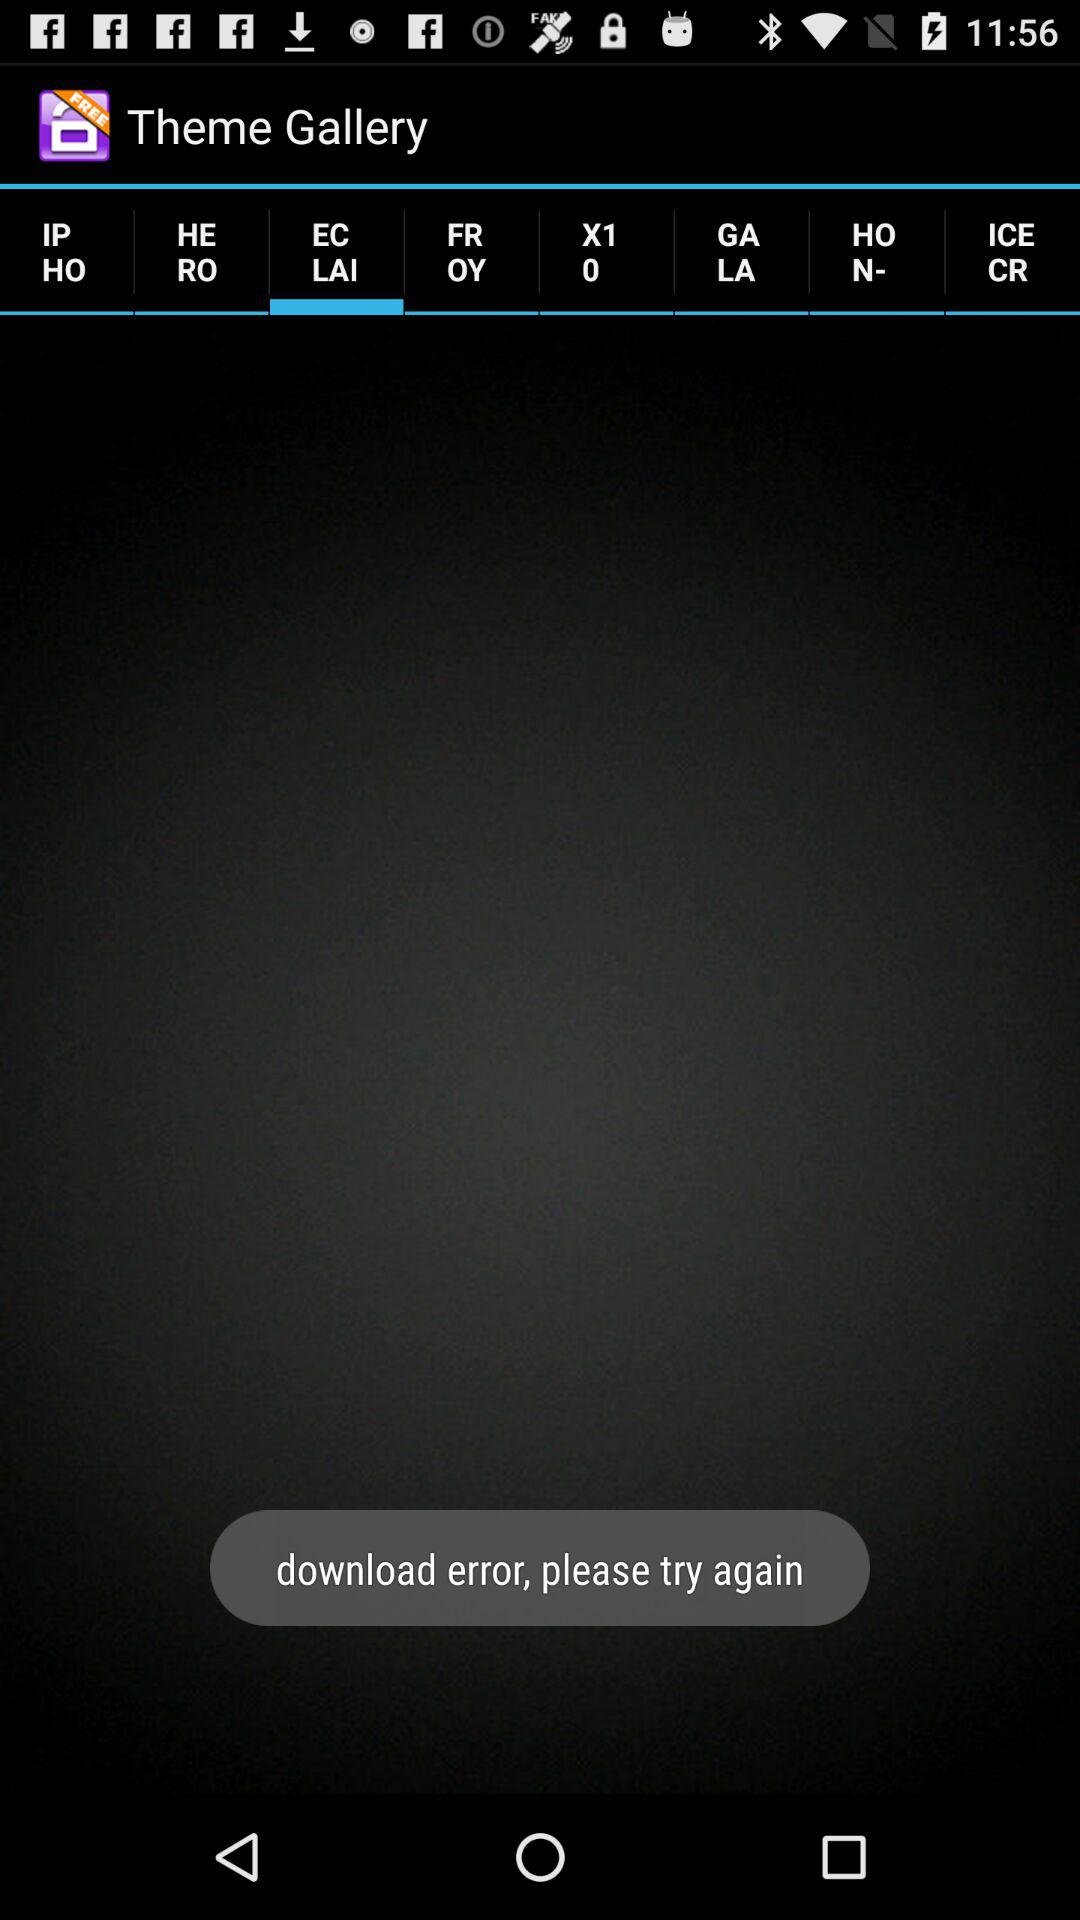What is the app name? The app name is "Theme Gallery". 